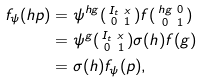Convert formula to latex. <formula><loc_0><loc_0><loc_500><loc_500>f _ { \psi } ( h p ) & = \psi ^ { h g } ( \begin{smallmatrix} I _ { t } & x \\ 0 & 1 \end{smallmatrix} ) f ( \begin{smallmatrix} h g & 0 \\ 0 & 1 \end{smallmatrix} ) \\ & = \psi ^ { g } ( \begin{smallmatrix} I _ { t } & x \\ 0 & 1 \end{smallmatrix} ) \sigma ( h ) f ( g ) \\ & = \sigma ( h ) f _ { \psi } ( p ) ,</formula> 